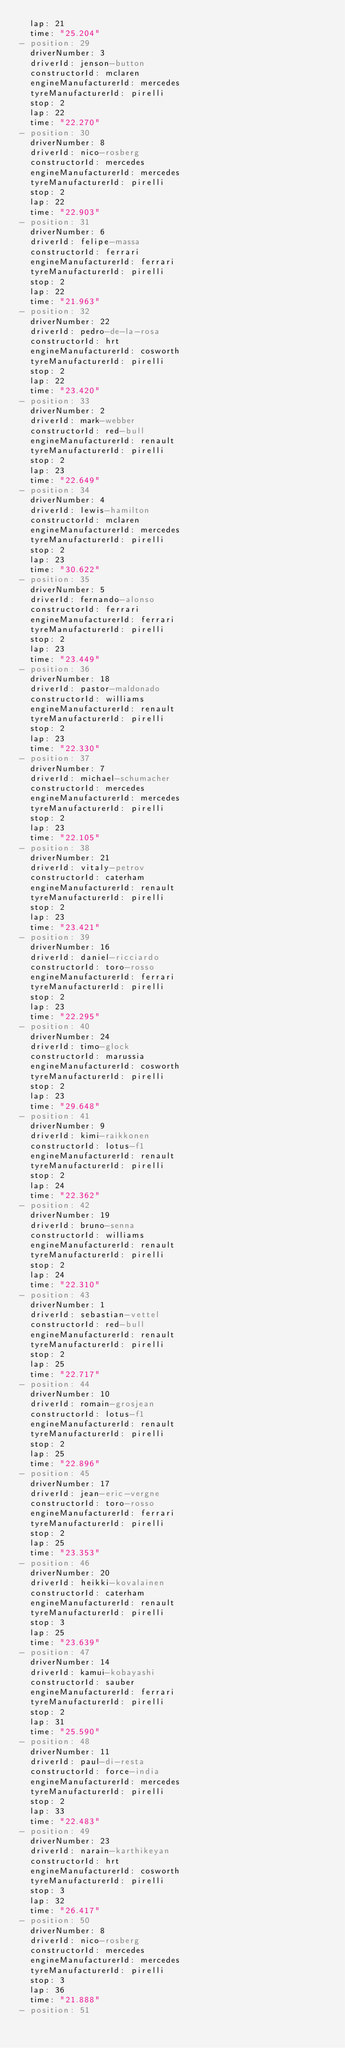Convert code to text. <code><loc_0><loc_0><loc_500><loc_500><_YAML_>  lap: 21
  time: "25.204"
- position: 29
  driverNumber: 3
  driverId: jenson-button
  constructorId: mclaren
  engineManufacturerId: mercedes
  tyreManufacturerId: pirelli
  stop: 2
  lap: 22
  time: "22.270"
- position: 30
  driverNumber: 8
  driverId: nico-rosberg
  constructorId: mercedes
  engineManufacturerId: mercedes
  tyreManufacturerId: pirelli
  stop: 2
  lap: 22
  time: "22.903"
- position: 31
  driverNumber: 6
  driverId: felipe-massa
  constructorId: ferrari
  engineManufacturerId: ferrari
  tyreManufacturerId: pirelli
  stop: 2
  lap: 22
  time: "21.963"
- position: 32
  driverNumber: 22
  driverId: pedro-de-la-rosa
  constructorId: hrt
  engineManufacturerId: cosworth
  tyreManufacturerId: pirelli
  stop: 2
  lap: 22
  time: "23.420"
- position: 33
  driverNumber: 2
  driverId: mark-webber
  constructorId: red-bull
  engineManufacturerId: renault
  tyreManufacturerId: pirelli
  stop: 2
  lap: 23
  time: "22.649"
- position: 34
  driverNumber: 4
  driverId: lewis-hamilton
  constructorId: mclaren
  engineManufacturerId: mercedes
  tyreManufacturerId: pirelli
  stop: 2
  lap: 23
  time: "30.622"
- position: 35
  driverNumber: 5
  driverId: fernando-alonso
  constructorId: ferrari
  engineManufacturerId: ferrari
  tyreManufacturerId: pirelli
  stop: 2
  lap: 23
  time: "23.449"
- position: 36
  driverNumber: 18
  driverId: pastor-maldonado
  constructorId: williams
  engineManufacturerId: renault
  tyreManufacturerId: pirelli
  stop: 2
  lap: 23
  time: "22.330"
- position: 37
  driverNumber: 7
  driverId: michael-schumacher
  constructorId: mercedes
  engineManufacturerId: mercedes
  tyreManufacturerId: pirelli
  stop: 2
  lap: 23
  time: "22.105"
- position: 38
  driverNumber: 21
  driverId: vitaly-petrov
  constructorId: caterham
  engineManufacturerId: renault
  tyreManufacturerId: pirelli
  stop: 2
  lap: 23
  time: "23.421"
- position: 39
  driverNumber: 16
  driverId: daniel-ricciardo
  constructorId: toro-rosso
  engineManufacturerId: ferrari
  tyreManufacturerId: pirelli
  stop: 2
  lap: 23
  time: "22.295"
- position: 40
  driverNumber: 24
  driverId: timo-glock
  constructorId: marussia
  engineManufacturerId: cosworth
  tyreManufacturerId: pirelli
  stop: 2
  lap: 23
  time: "29.648"
- position: 41
  driverNumber: 9
  driverId: kimi-raikkonen
  constructorId: lotus-f1
  engineManufacturerId: renault
  tyreManufacturerId: pirelli
  stop: 2
  lap: 24
  time: "22.362"
- position: 42
  driverNumber: 19
  driverId: bruno-senna
  constructorId: williams
  engineManufacturerId: renault
  tyreManufacturerId: pirelli
  stop: 2
  lap: 24
  time: "22.310"
- position: 43
  driverNumber: 1
  driverId: sebastian-vettel
  constructorId: red-bull
  engineManufacturerId: renault
  tyreManufacturerId: pirelli
  stop: 2
  lap: 25
  time: "22.717"
- position: 44
  driverNumber: 10
  driverId: romain-grosjean
  constructorId: lotus-f1
  engineManufacturerId: renault
  tyreManufacturerId: pirelli
  stop: 2
  lap: 25
  time: "22.896"
- position: 45
  driverNumber: 17
  driverId: jean-eric-vergne
  constructorId: toro-rosso
  engineManufacturerId: ferrari
  tyreManufacturerId: pirelli
  stop: 2
  lap: 25
  time: "23.353"
- position: 46
  driverNumber: 20
  driverId: heikki-kovalainen
  constructorId: caterham
  engineManufacturerId: renault
  tyreManufacturerId: pirelli
  stop: 3
  lap: 25
  time: "23.639"
- position: 47
  driverNumber: 14
  driverId: kamui-kobayashi
  constructorId: sauber
  engineManufacturerId: ferrari
  tyreManufacturerId: pirelli
  stop: 2
  lap: 31
  time: "25.590"
- position: 48
  driverNumber: 11
  driverId: paul-di-resta
  constructorId: force-india
  engineManufacturerId: mercedes
  tyreManufacturerId: pirelli
  stop: 2
  lap: 33
  time: "22.483"
- position: 49
  driverNumber: 23
  driverId: narain-karthikeyan
  constructorId: hrt
  engineManufacturerId: cosworth
  tyreManufacturerId: pirelli
  stop: 3
  lap: 32
  time: "26.417"
- position: 50
  driverNumber: 8
  driverId: nico-rosberg
  constructorId: mercedes
  engineManufacturerId: mercedes
  tyreManufacturerId: pirelli
  stop: 3
  lap: 36
  time: "21.888"
- position: 51</code> 